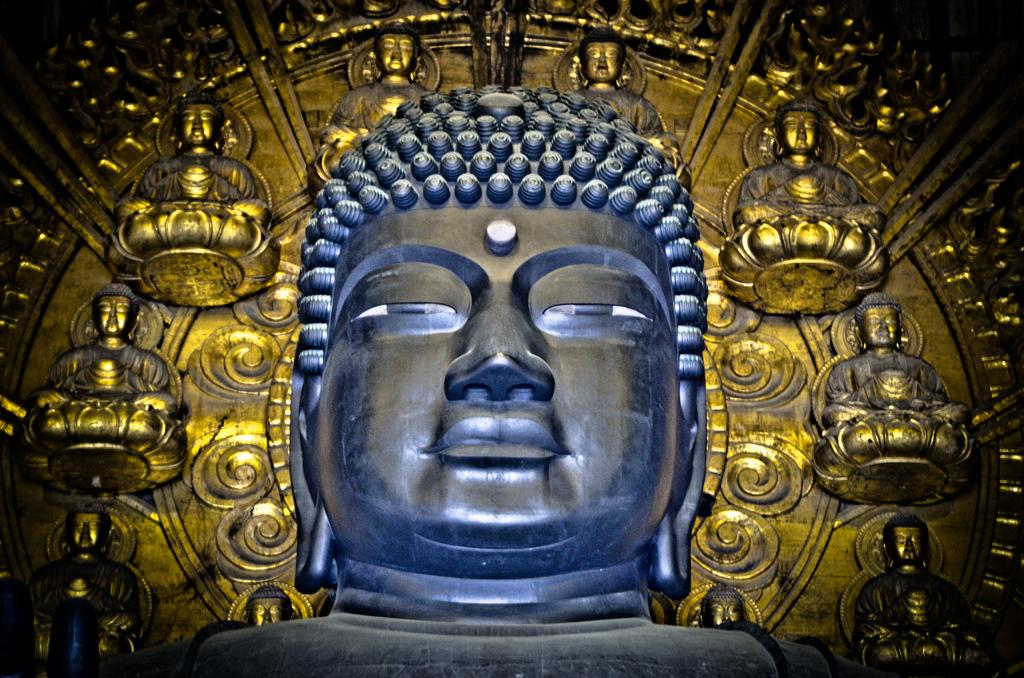What is the main subject of the image? There is a sculpture in the image. Can you describe any additional details about the sculpture? Unfortunately, the provided facts do not offer any additional details about the sculpture. What can be seen in the background of the image? There are carvings on metal in the background of the image. What type of advice does the manager give to the geese in the image? There is no manager or geese present in the image. Can you describe the snail's role in the image? There is no snail present in the image. 